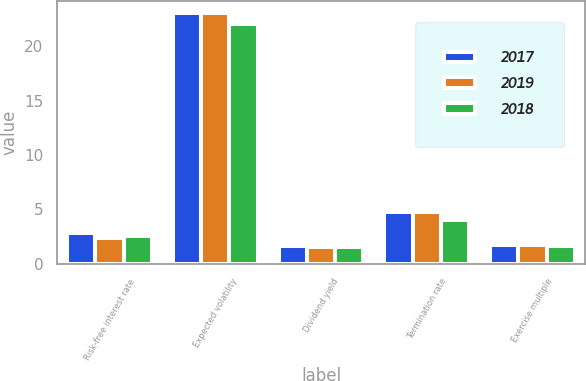Convert chart. <chart><loc_0><loc_0><loc_500><loc_500><stacked_bar_chart><ecel><fcel>Risk-free interest rate<fcel>Expected volatility<fcel>Dividend yield<fcel>Termination rate<fcel>Exercise multiple<nl><fcel>2017<fcel>2.8<fcel>23<fcel>1.61<fcel>4.8<fcel>1.75<nl><fcel>2019<fcel>2.4<fcel>23<fcel>1.57<fcel>4.8<fcel>1.75<nl><fcel>2018<fcel>2.6<fcel>22<fcel>1.58<fcel>4<fcel>1.62<nl></chart> 